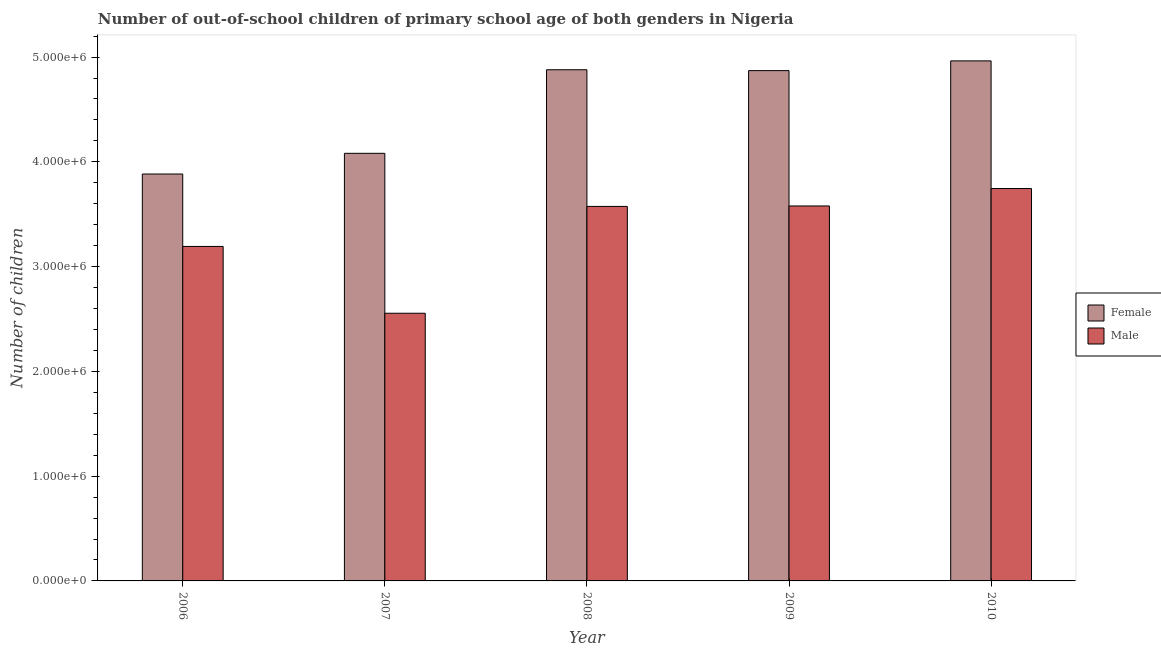How many different coloured bars are there?
Make the answer very short. 2. How many groups of bars are there?
Give a very brief answer. 5. Are the number of bars per tick equal to the number of legend labels?
Your response must be concise. Yes. Are the number of bars on each tick of the X-axis equal?
Your answer should be compact. Yes. How many bars are there on the 1st tick from the left?
Provide a short and direct response. 2. How many bars are there on the 1st tick from the right?
Offer a very short reply. 2. What is the label of the 1st group of bars from the left?
Offer a terse response. 2006. In how many cases, is the number of bars for a given year not equal to the number of legend labels?
Your response must be concise. 0. What is the number of female out-of-school students in 2010?
Keep it short and to the point. 4.96e+06. Across all years, what is the maximum number of male out-of-school students?
Give a very brief answer. 3.75e+06. Across all years, what is the minimum number of female out-of-school students?
Make the answer very short. 3.88e+06. In which year was the number of female out-of-school students minimum?
Give a very brief answer. 2006. What is the total number of male out-of-school students in the graph?
Offer a terse response. 1.66e+07. What is the difference between the number of female out-of-school students in 2006 and that in 2010?
Give a very brief answer. -1.08e+06. What is the difference between the number of male out-of-school students in 2008 and the number of female out-of-school students in 2007?
Keep it short and to the point. 1.02e+06. What is the average number of female out-of-school students per year?
Offer a very short reply. 4.54e+06. What is the ratio of the number of male out-of-school students in 2006 to that in 2008?
Offer a very short reply. 0.89. Is the number of female out-of-school students in 2007 less than that in 2008?
Provide a succinct answer. Yes. What is the difference between the highest and the second highest number of male out-of-school students?
Your answer should be compact. 1.66e+05. What is the difference between the highest and the lowest number of male out-of-school students?
Give a very brief answer. 1.19e+06. In how many years, is the number of female out-of-school students greater than the average number of female out-of-school students taken over all years?
Your answer should be very brief. 3. What does the 1st bar from the left in 2006 represents?
Your answer should be very brief. Female. Are all the bars in the graph horizontal?
Provide a succinct answer. No. How many legend labels are there?
Make the answer very short. 2. What is the title of the graph?
Ensure brevity in your answer.  Number of out-of-school children of primary school age of both genders in Nigeria. What is the label or title of the X-axis?
Keep it short and to the point. Year. What is the label or title of the Y-axis?
Your answer should be very brief. Number of children. What is the Number of children in Female in 2006?
Keep it short and to the point. 3.88e+06. What is the Number of children in Male in 2006?
Provide a succinct answer. 3.19e+06. What is the Number of children in Female in 2007?
Your answer should be very brief. 4.08e+06. What is the Number of children of Male in 2007?
Provide a short and direct response. 2.55e+06. What is the Number of children in Female in 2008?
Your answer should be compact. 4.88e+06. What is the Number of children in Male in 2008?
Your answer should be very brief. 3.57e+06. What is the Number of children in Female in 2009?
Make the answer very short. 4.87e+06. What is the Number of children of Male in 2009?
Offer a very short reply. 3.58e+06. What is the Number of children in Female in 2010?
Your answer should be very brief. 4.96e+06. What is the Number of children of Male in 2010?
Keep it short and to the point. 3.75e+06. Across all years, what is the maximum Number of children of Female?
Ensure brevity in your answer.  4.96e+06. Across all years, what is the maximum Number of children in Male?
Offer a very short reply. 3.75e+06. Across all years, what is the minimum Number of children of Female?
Give a very brief answer. 3.88e+06. Across all years, what is the minimum Number of children in Male?
Offer a very short reply. 2.55e+06. What is the total Number of children in Female in the graph?
Give a very brief answer. 2.27e+07. What is the total Number of children of Male in the graph?
Keep it short and to the point. 1.66e+07. What is the difference between the Number of children in Female in 2006 and that in 2007?
Keep it short and to the point. -1.97e+05. What is the difference between the Number of children of Male in 2006 and that in 2007?
Your answer should be very brief. 6.38e+05. What is the difference between the Number of children of Female in 2006 and that in 2008?
Offer a terse response. -9.95e+05. What is the difference between the Number of children in Male in 2006 and that in 2008?
Provide a succinct answer. -3.82e+05. What is the difference between the Number of children of Female in 2006 and that in 2009?
Keep it short and to the point. -9.87e+05. What is the difference between the Number of children in Male in 2006 and that in 2009?
Offer a very short reply. -3.86e+05. What is the difference between the Number of children in Female in 2006 and that in 2010?
Make the answer very short. -1.08e+06. What is the difference between the Number of children of Male in 2006 and that in 2010?
Ensure brevity in your answer.  -5.53e+05. What is the difference between the Number of children of Female in 2007 and that in 2008?
Provide a short and direct response. -7.98e+05. What is the difference between the Number of children in Male in 2007 and that in 2008?
Keep it short and to the point. -1.02e+06. What is the difference between the Number of children of Female in 2007 and that in 2009?
Make the answer very short. -7.89e+05. What is the difference between the Number of children in Male in 2007 and that in 2009?
Give a very brief answer. -1.02e+06. What is the difference between the Number of children in Female in 2007 and that in 2010?
Offer a very short reply. -8.82e+05. What is the difference between the Number of children of Male in 2007 and that in 2010?
Offer a very short reply. -1.19e+06. What is the difference between the Number of children in Female in 2008 and that in 2009?
Ensure brevity in your answer.  8178. What is the difference between the Number of children of Male in 2008 and that in 2009?
Give a very brief answer. -4340. What is the difference between the Number of children of Female in 2008 and that in 2010?
Ensure brevity in your answer.  -8.48e+04. What is the difference between the Number of children of Male in 2008 and that in 2010?
Provide a short and direct response. -1.71e+05. What is the difference between the Number of children in Female in 2009 and that in 2010?
Your response must be concise. -9.30e+04. What is the difference between the Number of children in Male in 2009 and that in 2010?
Your answer should be compact. -1.66e+05. What is the difference between the Number of children of Female in 2006 and the Number of children of Male in 2007?
Offer a terse response. 1.33e+06. What is the difference between the Number of children in Female in 2006 and the Number of children in Male in 2008?
Offer a very short reply. 3.09e+05. What is the difference between the Number of children of Female in 2006 and the Number of children of Male in 2009?
Provide a succinct answer. 3.05e+05. What is the difference between the Number of children of Female in 2006 and the Number of children of Male in 2010?
Provide a succinct answer. 1.39e+05. What is the difference between the Number of children in Female in 2007 and the Number of children in Male in 2008?
Offer a very short reply. 5.07e+05. What is the difference between the Number of children in Female in 2007 and the Number of children in Male in 2009?
Provide a short and direct response. 5.02e+05. What is the difference between the Number of children in Female in 2007 and the Number of children in Male in 2010?
Your response must be concise. 3.36e+05. What is the difference between the Number of children of Female in 2008 and the Number of children of Male in 2009?
Your answer should be compact. 1.30e+06. What is the difference between the Number of children of Female in 2008 and the Number of children of Male in 2010?
Offer a terse response. 1.13e+06. What is the difference between the Number of children in Female in 2009 and the Number of children in Male in 2010?
Offer a very short reply. 1.13e+06. What is the average Number of children in Female per year?
Keep it short and to the point. 4.54e+06. What is the average Number of children of Male per year?
Your answer should be compact. 3.33e+06. In the year 2006, what is the difference between the Number of children in Female and Number of children in Male?
Keep it short and to the point. 6.91e+05. In the year 2007, what is the difference between the Number of children in Female and Number of children in Male?
Offer a terse response. 1.53e+06. In the year 2008, what is the difference between the Number of children in Female and Number of children in Male?
Make the answer very short. 1.30e+06. In the year 2009, what is the difference between the Number of children in Female and Number of children in Male?
Your answer should be very brief. 1.29e+06. In the year 2010, what is the difference between the Number of children in Female and Number of children in Male?
Offer a terse response. 1.22e+06. What is the ratio of the Number of children in Female in 2006 to that in 2007?
Your response must be concise. 0.95. What is the ratio of the Number of children in Male in 2006 to that in 2007?
Your answer should be very brief. 1.25. What is the ratio of the Number of children in Female in 2006 to that in 2008?
Offer a terse response. 0.8. What is the ratio of the Number of children in Male in 2006 to that in 2008?
Offer a terse response. 0.89. What is the ratio of the Number of children of Female in 2006 to that in 2009?
Provide a succinct answer. 0.8. What is the ratio of the Number of children of Male in 2006 to that in 2009?
Offer a terse response. 0.89. What is the ratio of the Number of children of Female in 2006 to that in 2010?
Offer a terse response. 0.78. What is the ratio of the Number of children of Male in 2006 to that in 2010?
Your answer should be very brief. 0.85. What is the ratio of the Number of children in Female in 2007 to that in 2008?
Keep it short and to the point. 0.84. What is the ratio of the Number of children in Male in 2007 to that in 2008?
Keep it short and to the point. 0.71. What is the ratio of the Number of children of Female in 2007 to that in 2009?
Your answer should be very brief. 0.84. What is the ratio of the Number of children of Male in 2007 to that in 2009?
Offer a terse response. 0.71. What is the ratio of the Number of children of Female in 2007 to that in 2010?
Ensure brevity in your answer.  0.82. What is the ratio of the Number of children of Male in 2007 to that in 2010?
Ensure brevity in your answer.  0.68. What is the ratio of the Number of children of Female in 2008 to that in 2009?
Your answer should be very brief. 1. What is the ratio of the Number of children of Male in 2008 to that in 2009?
Provide a succinct answer. 1. What is the ratio of the Number of children of Female in 2008 to that in 2010?
Offer a very short reply. 0.98. What is the ratio of the Number of children in Male in 2008 to that in 2010?
Your answer should be compact. 0.95. What is the ratio of the Number of children of Female in 2009 to that in 2010?
Your response must be concise. 0.98. What is the ratio of the Number of children of Male in 2009 to that in 2010?
Your answer should be compact. 0.96. What is the difference between the highest and the second highest Number of children in Female?
Offer a very short reply. 8.48e+04. What is the difference between the highest and the second highest Number of children in Male?
Provide a short and direct response. 1.66e+05. What is the difference between the highest and the lowest Number of children of Female?
Offer a very short reply. 1.08e+06. What is the difference between the highest and the lowest Number of children of Male?
Give a very brief answer. 1.19e+06. 